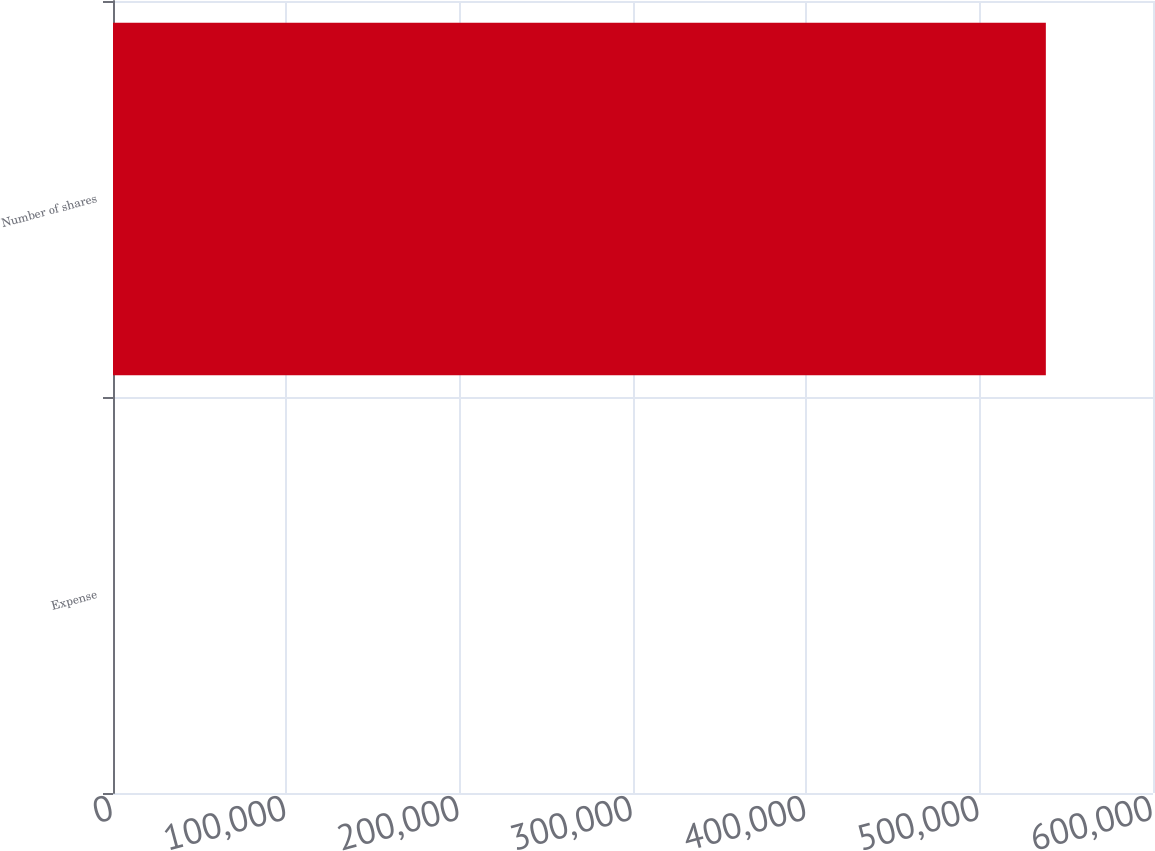Convert chart to OTSL. <chart><loc_0><loc_0><loc_500><loc_500><bar_chart><fcel>Expense<fcel>Number of shares<nl><fcel>26.3<fcel>538180<nl></chart> 